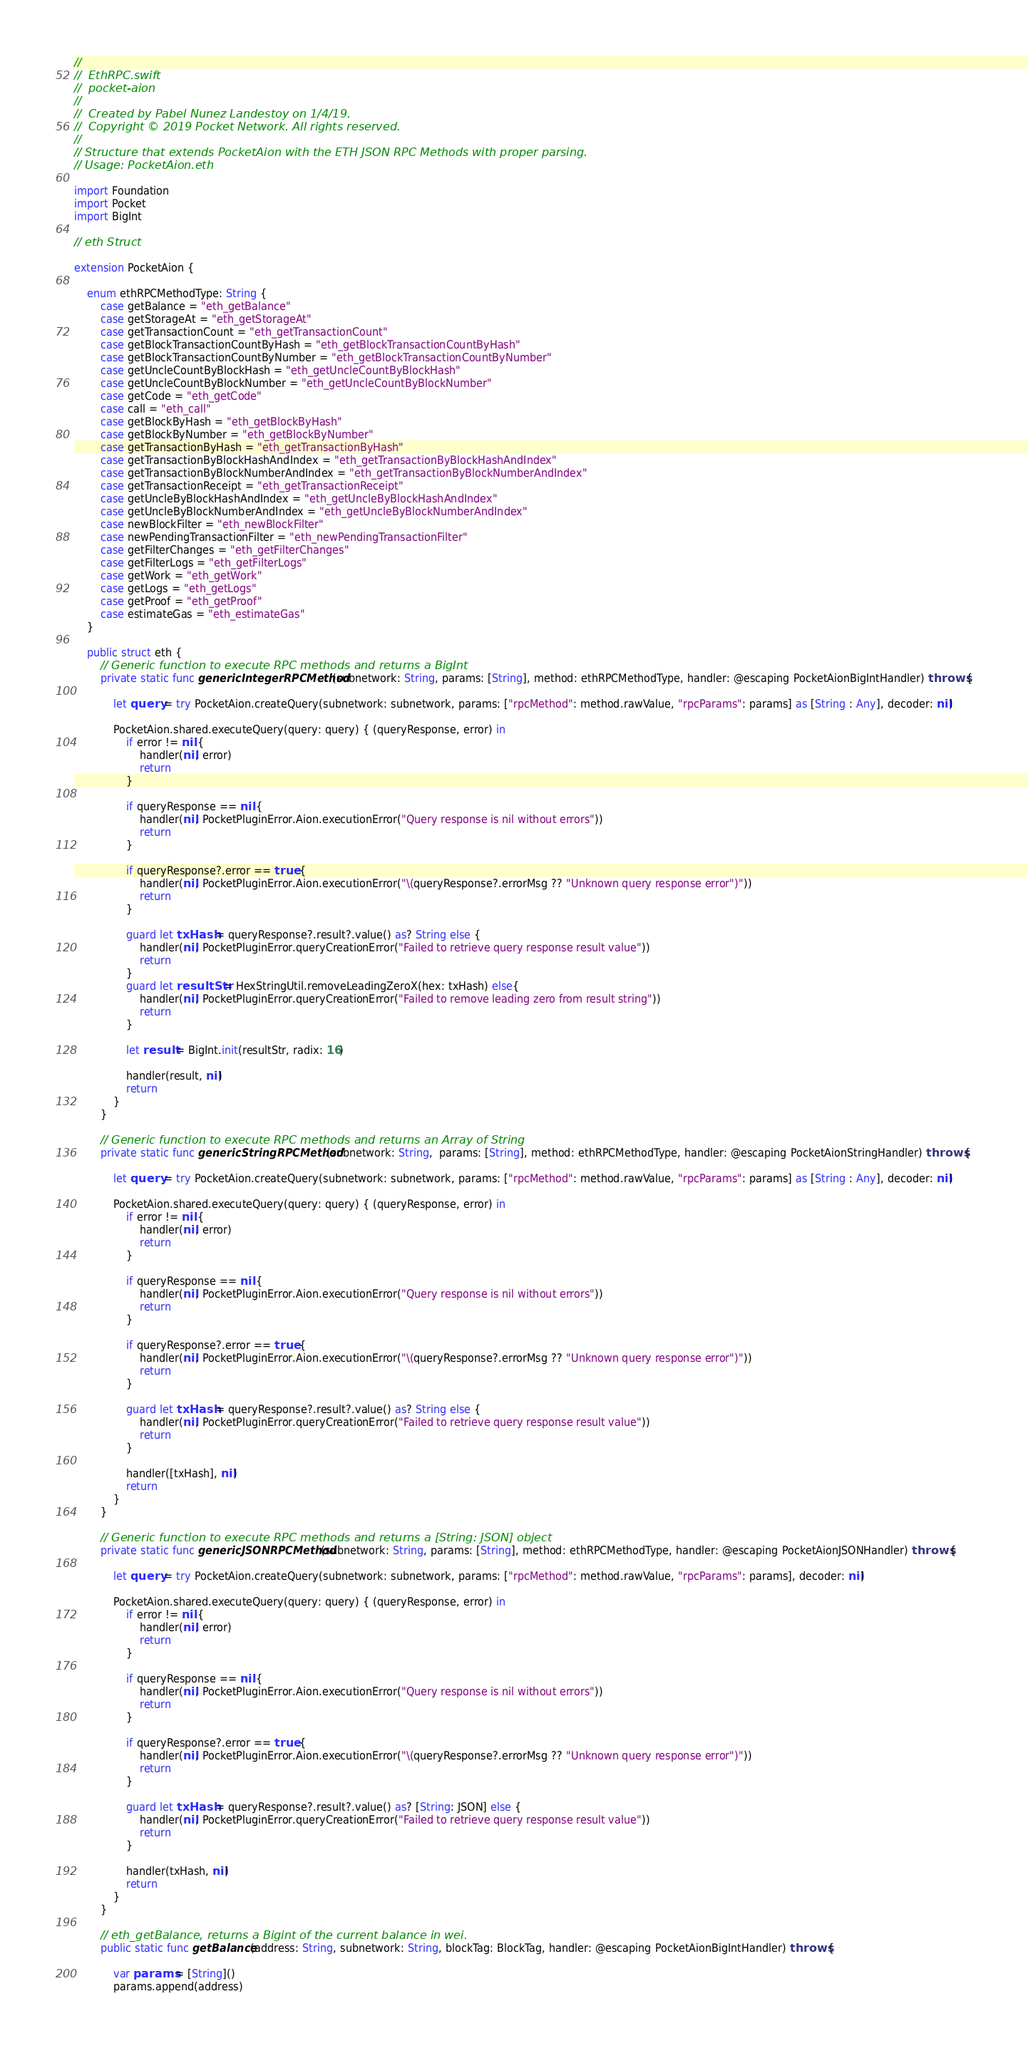Convert code to text. <code><loc_0><loc_0><loc_500><loc_500><_Swift_>//
//  EthRPC.swift
//  pocket-aion
//
//  Created by Pabel Nunez Landestoy on 1/4/19.
//  Copyright © 2019 Pocket Network. All rights reserved.
//
// Structure that extends PocketAion with the ETH JSON RPC Methods with proper parsing.
// Usage: PocketAion.eth

import Foundation
import Pocket
import BigInt

// eth Struct

extension PocketAion {
    
    enum ethRPCMethodType: String {
        case getBalance = "eth_getBalance"
        case getStorageAt = "eth_getStorageAt"
        case getTransactionCount = "eth_getTransactionCount"
        case getBlockTransactionCountByHash = "eth_getBlockTransactionCountByHash"
        case getBlockTransactionCountByNumber = "eth_getBlockTransactionCountByNumber"
        case getUncleCountByBlockHash = "eth_getUncleCountByBlockHash"
        case getUncleCountByBlockNumber = "eth_getUncleCountByBlockNumber"
        case getCode = "eth_getCode"
        case call = "eth_call"
        case getBlockByHash = "eth_getBlockByHash"
        case getBlockByNumber = "eth_getBlockByNumber"
        case getTransactionByHash = "eth_getTransactionByHash"
        case getTransactionByBlockHashAndIndex = "eth_getTransactionByBlockHashAndIndex"
        case getTransactionByBlockNumberAndIndex = "eth_getTransactionByBlockNumberAndIndex"
        case getTransactionReceipt = "eth_getTransactionReceipt"
        case getUncleByBlockHashAndIndex = "eth_getUncleByBlockHashAndIndex"
        case getUncleByBlockNumberAndIndex = "eth_getUncleByBlockNumberAndIndex"
        case newBlockFilter = "eth_newBlockFilter"
        case newPendingTransactionFilter = "eth_newPendingTransactionFilter"
        case getFilterChanges = "eth_getFilterChanges"
        case getFilterLogs = "eth_getFilterLogs"
        case getWork = "eth_getWork"
        case getLogs = "eth_getLogs"
        case getProof = "eth_getProof"
        case estimateGas = "eth_estimateGas"
    }
    
    public struct eth {
        // Generic function to execute RPC methods and returns a BigInt
        private static func genericIntegerRPCMethod(subnetwork: String, params: [String], method: ethRPCMethodType, handler: @escaping PocketAionBigIntHandler) throws {
            
            let query = try PocketAion.createQuery(subnetwork: subnetwork, params: ["rpcMethod": method.rawValue, "rpcParams": params] as [String : Any], decoder: nil)
            
            PocketAion.shared.executeQuery(query: query) { (queryResponse, error) in
                if error != nil {
                    handler(nil, error)
                    return
                }
                
                if queryResponse == nil {
                    handler(nil, PocketPluginError.Aion.executionError("Query response is nil without errors"))
                    return
                }
                
                if queryResponse?.error == true {
                    handler(nil, PocketPluginError.Aion.executionError("\(queryResponse?.errorMsg ?? "Unknown query response error")"))
                    return
                }
                
                guard let txHash = queryResponse?.result?.value() as? String else {
                    handler(nil, PocketPluginError.queryCreationError("Failed to retrieve query response result value"))
                    return
                }
                guard let resultStr = HexStringUtil.removeLeadingZeroX(hex: txHash) else{
                    handler(nil, PocketPluginError.queryCreationError("Failed to remove leading zero from result string"))
                    return
                }
                
                let result = BigInt.init(resultStr, radix: 16)
                
                handler(result, nil)
                return
            }
        }
        
        // Generic function to execute RPC methods and returns an Array of String
        private static func genericStringRPCMethod(subnetwork: String,  params: [String], method: ethRPCMethodType, handler: @escaping PocketAionStringHandler) throws {
            
            let query = try PocketAion.createQuery(subnetwork: subnetwork, params: ["rpcMethod": method.rawValue, "rpcParams": params] as [String : Any], decoder: nil)
            
            PocketAion.shared.executeQuery(query: query) { (queryResponse, error) in
                if error != nil {
                    handler(nil, error)
                    return
                }
                
                if queryResponse == nil {
                    handler(nil, PocketPluginError.Aion.executionError("Query response is nil without errors"))
                    return
                }
                
                if queryResponse?.error == true {
                    handler(nil, PocketPluginError.Aion.executionError("\(queryResponse?.errorMsg ?? "Unknown query response error")"))
                    return
                }
                
                guard let txHash = queryResponse?.result?.value() as? String else {
                    handler(nil, PocketPluginError.queryCreationError("Failed to retrieve query response result value"))
                    return
                }
                
                handler([txHash], nil)
                return
            }
        }
        
        // Generic function to execute RPC methods and returns a [String: JSON] object
        private static func genericJSONRPCMethod(subnetwork: String, params: [String], method: ethRPCMethodType, handler: @escaping PocketAionJSONHandler) throws {
            
            let query = try PocketAion.createQuery(subnetwork: subnetwork, params: ["rpcMethod": method.rawValue, "rpcParams": params], decoder: nil)
            
            PocketAion.shared.executeQuery(query: query) { (queryResponse, error) in
                if error != nil {
                    handler(nil, error)
                    return
                }
                
                if queryResponse == nil {
                    handler(nil, PocketPluginError.Aion.executionError("Query response is nil without errors"))
                    return
                }
                
                if queryResponse?.error == true {
                    handler(nil, PocketPluginError.Aion.executionError("\(queryResponse?.errorMsg ?? "Unknown query response error")"))
                    return
                }
                
                guard let txHash = queryResponse?.result?.value() as? [String: JSON] else {
                    handler(nil, PocketPluginError.queryCreationError("Failed to retrieve query response result value"))
                    return
                }
                
                handler(txHash, nil)
                return
            }
        }
        
        // eth_getBalance, returns a Bigint of the current balance in wei.
        public static func getBalance(address: String, subnetwork: String, blockTag: BlockTag, handler: @escaping PocketAionBigIntHandler) throws {
            
            var params = [String]()
            params.append(address)</code> 